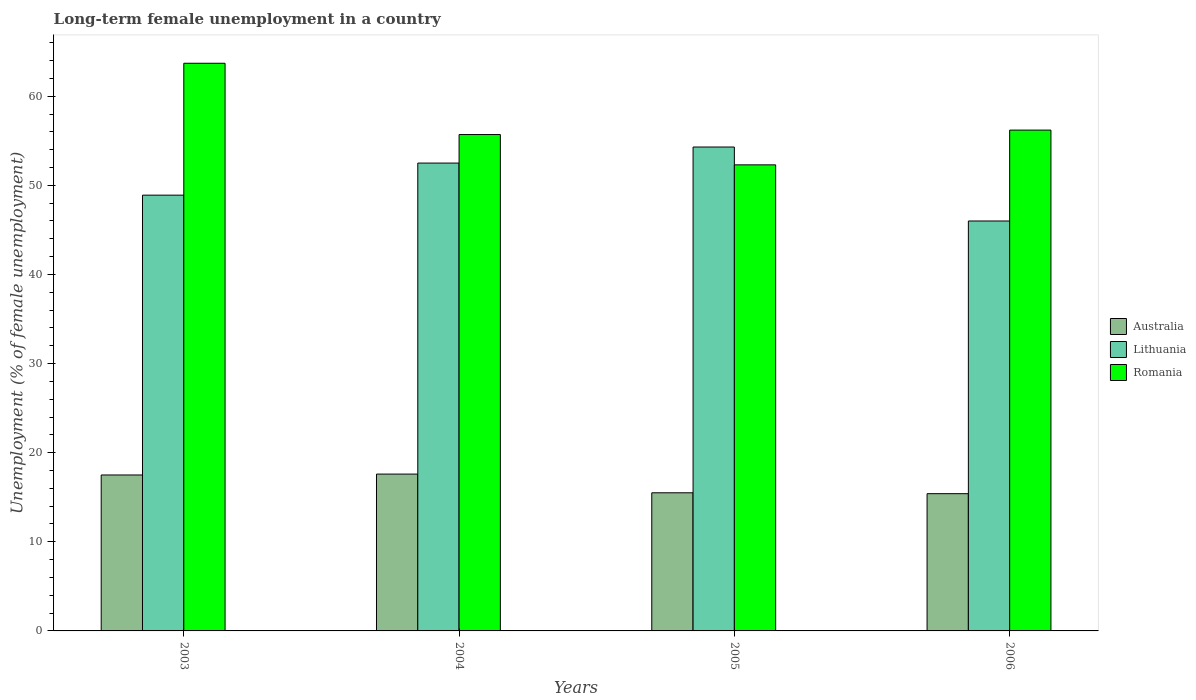How many different coloured bars are there?
Provide a short and direct response. 3. How many groups of bars are there?
Your answer should be very brief. 4. How many bars are there on the 2nd tick from the left?
Offer a very short reply. 3. What is the label of the 2nd group of bars from the left?
Provide a succinct answer. 2004. What is the percentage of long-term unemployed female population in Romania in 2004?
Provide a succinct answer. 55.7. Across all years, what is the maximum percentage of long-term unemployed female population in Lithuania?
Offer a very short reply. 54.3. Across all years, what is the minimum percentage of long-term unemployed female population in Australia?
Ensure brevity in your answer.  15.4. In which year was the percentage of long-term unemployed female population in Romania minimum?
Give a very brief answer. 2005. What is the difference between the percentage of long-term unemployed female population in Lithuania in 2004 and that in 2005?
Offer a terse response. -1.8. What is the difference between the percentage of long-term unemployed female population in Australia in 2003 and the percentage of long-term unemployed female population in Romania in 2005?
Give a very brief answer. -34.8. What is the average percentage of long-term unemployed female population in Lithuania per year?
Provide a short and direct response. 50.43. In the year 2003, what is the difference between the percentage of long-term unemployed female population in Lithuania and percentage of long-term unemployed female population in Australia?
Your answer should be very brief. 31.4. What is the ratio of the percentage of long-term unemployed female population in Romania in 2003 to that in 2006?
Offer a terse response. 1.13. What is the difference between the highest and the lowest percentage of long-term unemployed female population in Lithuania?
Keep it short and to the point. 8.3. In how many years, is the percentage of long-term unemployed female population in Romania greater than the average percentage of long-term unemployed female population in Romania taken over all years?
Offer a terse response. 1. Is the sum of the percentage of long-term unemployed female population in Romania in 2003 and 2004 greater than the maximum percentage of long-term unemployed female population in Australia across all years?
Provide a succinct answer. Yes. What does the 3rd bar from the left in 2004 represents?
Your response must be concise. Romania. What does the 1st bar from the right in 2006 represents?
Offer a terse response. Romania. How many bars are there?
Provide a short and direct response. 12. What is the difference between two consecutive major ticks on the Y-axis?
Ensure brevity in your answer.  10. Does the graph contain any zero values?
Ensure brevity in your answer.  No. Does the graph contain grids?
Offer a terse response. No. How many legend labels are there?
Your answer should be compact. 3. How are the legend labels stacked?
Your answer should be compact. Vertical. What is the title of the graph?
Offer a very short reply. Long-term female unemployment in a country. Does "Angola" appear as one of the legend labels in the graph?
Your answer should be compact. No. What is the label or title of the X-axis?
Your answer should be compact. Years. What is the label or title of the Y-axis?
Offer a terse response. Unemployment (% of female unemployment). What is the Unemployment (% of female unemployment) of Lithuania in 2003?
Your response must be concise. 48.9. What is the Unemployment (% of female unemployment) in Romania in 2003?
Your answer should be very brief. 63.7. What is the Unemployment (% of female unemployment) in Australia in 2004?
Provide a succinct answer. 17.6. What is the Unemployment (% of female unemployment) in Lithuania in 2004?
Your answer should be very brief. 52.5. What is the Unemployment (% of female unemployment) of Romania in 2004?
Give a very brief answer. 55.7. What is the Unemployment (% of female unemployment) of Lithuania in 2005?
Provide a succinct answer. 54.3. What is the Unemployment (% of female unemployment) in Romania in 2005?
Provide a short and direct response. 52.3. What is the Unemployment (% of female unemployment) of Australia in 2006?
Your answer should be very brief. 15.4. What is the Unemployment (% of female unemployment) in Lithuania in 2006?
Provide a succinct answer. 46. What is the Unemployment (% of female unemployment) of Romania in 2006?
Make the answer very short. 56.2. Across all years, what is the maximum Unemployment (% of female unemployment) of Australia?
Make the answer very short. 17.6. Across all years, what is the maximum Unemployment (% of female unemployment) of Lithuania?
Offer a terse response. 54.3. Across all years, what is the maximum Unemployment (% of female unemployment) in Romania?
Your answer should be very brief. 63.7. Across all years, what is the minimum Unemployment (% of female unemployment) of Australia?
Provide a short and direct response. 15.4. Across all years, what is the minimum Unemployment (% of female unemployment) of Romania?
Provide a succinct answer. 52.3. What is the total Unemployment (% of female unemployment) of Australia in the graph?
Ensure brevity in your answer.  66. What is the total Unemployment (% of female unemployment) in Lithuania in the graph?
Your response must be concise. 201.7. What is the total Unemployment (% of female unemployment) of Romania in the graph?
Your answer should be compact. 227.9. What is the difference between the Unemployment (% of female unemployment) in Romania in 2003 and that in 2004?
Give a very brief answer. 8. What is the difference between the Unemployment (% of female unemployment) in Romania in 2003 and that in 2005?
Offer a very short reply. 11.4. What is the difference between the Unemployment (% of female unemployment) of Lithuania in 2003 and that in 2006?
Provide a succinct answer. 2.9. What is the difference between the Unemployment (% of female unemployment) of Romania in 2004 and that in 2005?
Ensure brevity in your answer.  3.4. What is the difference between the Unemployment (% of female unemployment) of Australia in 2004 and that in 2006?
Keep it short and to the point. 2.2. What is the difference between the Unemployment (% of female unemployment) in Lithuania in 2004 and that in 2006?
Offer a very short reply. 6.5. What is the difference between the Unemployment (% of female unemployment) in Australia in 2003 and the Unemployment (% of female unemployment) in Lithuania in 2004?
Give a very brief answer. -35. What is the difference between the Unemployment (% of female unemployment) of Australia in 2003 and the Unemployment (% of female unemployment) of Romania in 2004?
Give a very brief answer. -38.2. What is the difference between the Unemployment (% of female unemployment) in Lithuania in 2003 and the Unemployment (% of female unemployment) in Romania in 2004?
Provide a succinct answer. -6.8. What is the difference between the Unemployment (% of female unemployment) in Australia in 2003 and the Unemployment (% of female unemployment) in Lithuania in 2005?
Make the answer very short. -36.8. What is the difference between the Unemployment (% of female unemployment) in Australia in 2003 and the Unemployment (% of female unemployment) in Romania in 2005?
Provide a succinct answer. -34.8. What is the difference between the Unemployment (% of female unemployment) in Lithuania in 2003 and the Unemployment (% of female unemployment) in Romania in 2005?
Your answer should be compact. -3.4. What is the difference between the Unemployment (% of female unemployment) of Australia in 2003 and the Unemployment (% of female unemployment) of Lithuania in 2006?
Provide a succinct answer. -28.5. What is the difference between the Unemployment (% of female unemployment) in Australia in 2003 and the Unemployment (% of female unemployment) in Romania in 2006?
Offer a terse response. -38.7. What is the difference between the Unemployment (% of female unemployment) in Australia in 2004 and the Unemployment (% of female unemployment) in Lithuania in 2005?
Offer a very short reply. -36.7. What is the difference between the Unemployment (% of female unemployment) in Australia in 2004 and the Unemployment (% of female unemployment) in Romania in 2005?
Your answer should be compact. -34.7. What is the difference between the Unemployment (% of female unemployment) in Australia in 2004 and the Unemployment (% of female unemployment) in Lithuania in 2006?
Provide a short and direct response. -28.4. What is the difference between the Unemployment (% of female unemployment) in Australia in 2004 and the Unemployment (% of female unemployment) in Romania in 2006?
Make the answer very short. -38.6. What is the difference between the Unemployment (% of female unemployment) in Lithuania in 2004 and the Unemployment (% of female unemployment) in Romania in 2006?
Make the answer very short. -3.7. What is the difference between the Unemployment (% of female unemployment) of Australia in 2005 and the Unemployment (% of female unemployment) of Lithuania in 2006?
Offer a terse response. -30.5. What is the difference between the Unemployment (% of female unemployment) of Australia in 2005 and the Unemployment (% of female unemployment) of Romania in 2006?
Provide a succinct answer. -40.7. What is the average Unemployment (% of female unemployment) in Lithuania per year?
Ensure brevity in your answer.  50.42. What is the average Unemployment (% of female unemployment) in Romania per year?
Give a very brief answer. 56.98. In the year 2003, what is the difference between the Unemployment (% of female unemployment) of Australia and Unemployment (% of female unemployment) of Lithuania?
Give a very brief answer. -31.4. In the year 2003, what is the difference between the Unemployment (% of female unemployment) in Australia and Unemployment (% of female unemployment) in Romania?
Offer a terse response. -46.2. In the year 2003, what is the difference between the Unemployment (% of female unemployment) of Lithuania and Unemployment (% of female unemployment) of Romania?
Give a very brief answer. -14.8. In the year 2004, what is the difference between the Unemployment (% of female unemployment) of Australia and Unemployment (% of female unemployment) of Lithuania?
Provide a succinct answer. -34.9. In the year 2004, what is the difference between the Unemployment (% of female unemployment) of Australia and Unemployment (% of female unemployment) of Romania?
Your answer should be compact. -38.1. In the year 2005, what is the difference between the Unemployment (% of female unemployment) in Australia and Unemployment (% of female unemployment) in Lithuania?
Provide a succinct answer. -38.8. In the year 2005, what is the difference between the Unemployment (% of female unemployment) in Australia and Unemployment (% of female unemployment) in Romania?
Give a very brief answer. -36.8. In the year 2006, what is the difference between the Unemployment (% of female unemployment) in Australia and Unemployment (% of female unemployment) in Lithuania?
Your answer should be compact. -30.6. In the year 2006, what is the difference between the Unemployment (% of female unemployment) of Australia and Unemployment (% of female unemployment) of Romania?
Your response must be concise. -40.8. What is the ratio of the Unemployment (% of female unemployment) of Australia in 2003 to that in 2004?
Give a very brief answer. 0.99. What is the ratio of the Unemployment (% of female unemployment) in Lithuania in 2003 to that in 2004?
Your answer should be compact. 0.93. What is the ratio of the Unemployment (% of female unemployment) in Romania in 2003 to that in 2004?
Provide a short and direct response. 1.14. What is the ratio of the Unemployment (% of female unemployment) in Australia in 2003 to that in 2005?
Your answer should be compact. 1.13. What is the ratio of the Unemployment (% of female unemployment) in Lithuania in 2003 to that in 2005?
Keep it short and to the point. 0.9. What is the ratio of the Unemployment (% of female unemployment) of Romania in 2003 to that in 2005?
Make the answer very short. 1.22. What is the ratio of the Unemployment (% of female unemployment) of Australia in 2003 to that in 2006?
Ensure brevity in your answer.  1.14. What is the ratio of the Unemployment (% of female unemployment) of Lithuania in 2003 to that in 2006?
Your response must be concise. 1.06. What is the ratio of the Unemployment (% of female unemployment) in Romania in 2003 to that in 2006?
Make the answer very short. 1.13. What is the ratio of the Unemployment (% of female unemployment) of Australia in 2004 to that in 2005?
Give a very brief answer. 1.14. What is the ratio of the Unemployment (% of female unemployment) of Lithuania in 2004 to that in 2005?
Your answer should be very brief. 0.97. What is the ratio of the Unemployment (% of female unemployment) in Romania in 2004 to that in 2005?
Offer a terse response. 1.06. What is the ratio of the Unemployment (% of female unemployment) in Lithuania in 2004 to that in 2006?
Offer a terse response. 1.14. What is the ratio of the Unemployment (% of female unemployment) in Australia in 2005 to that in 2006?
Make the answer very short. 1.01. What is the ratio of the Unemployment (% of female unemployment) in Lithuania in 2005 to that in 2006?
Give a very brief answer. 1.18. What is the ratio of the Unemployment (% of female unemployment) in Romania in 2005 to that in 2006?
Offer a terse response. 0.93. 